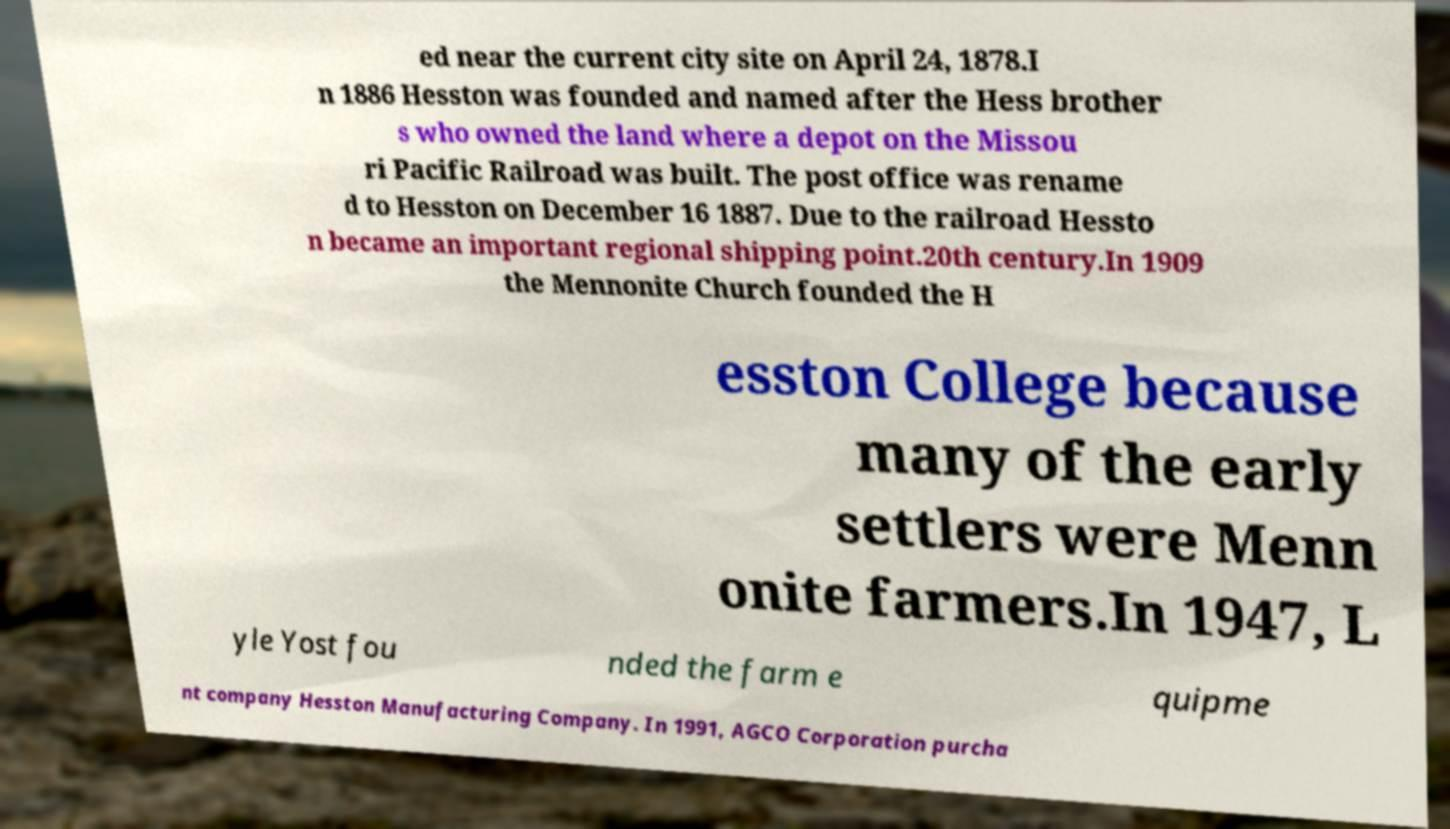What messages or text are displayed in this image? I need them in a readable, typed format. ed near the current city site on April 24, 1878.I n 1886 Hesston was founded and named after the Hess brother s who owned the land where a depot on the Missou ri Pacific Railroad was built. The post office was rename d to Hesston on December 16 1887. Due to the railroad Hessto n became an important regional shipping point.20th century.In 1909 the Mennonite Church founded the H esston College because many of the early settlers were Menn onite farmers.In 1947, L yle Yost fou nded the farm e quipme nt company Hesston Manufacturing Company. In 1991, AGCO Corporation purcha 